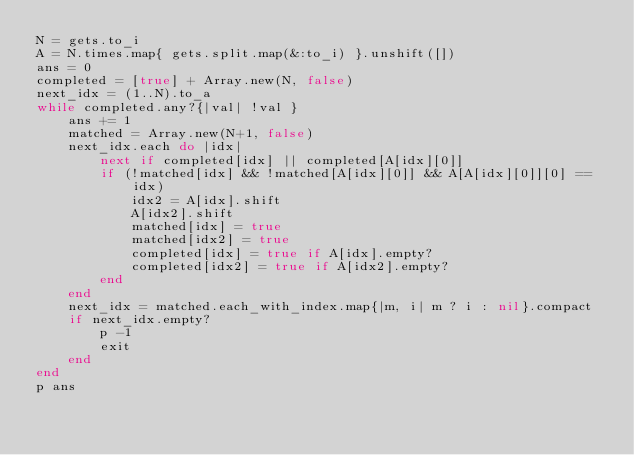Convert code to text. <code><loc_0><loc_0><loc_500><loc_500><_Ruby_>N = gets.to_i
A = N.times.map{ gets.split.map(&:to_i) }.unshift([])
ans = 0
completed = [true] + Array.new(N, false)
next_idx = (1..N).to_a
while completed.any?{|val| !val }
    ans += 1
    matched = Array.new(N+1, false)
    next_idx.each do |idx|
        next if completed[idx] || completed[A[idx][0]]
        if (!matched[idx] && !matched[A[idx][0]] && A[A[idx][0]][0] == idx)
            idx2 = A[idx].shift
            A[idx2].shift
            matched[idx] = true
            matched[idx2] = true
            completed[idx] = true if A[idx].empty?
            completed[idx2] = true if A[idx2].empty?
        end
    end
    next_idx = matched.each_with_index.map{|m, i| m ? i : nil}.compact
    if next_idx.empty?
        p -1
        exit
    end
end
p ans</code> 